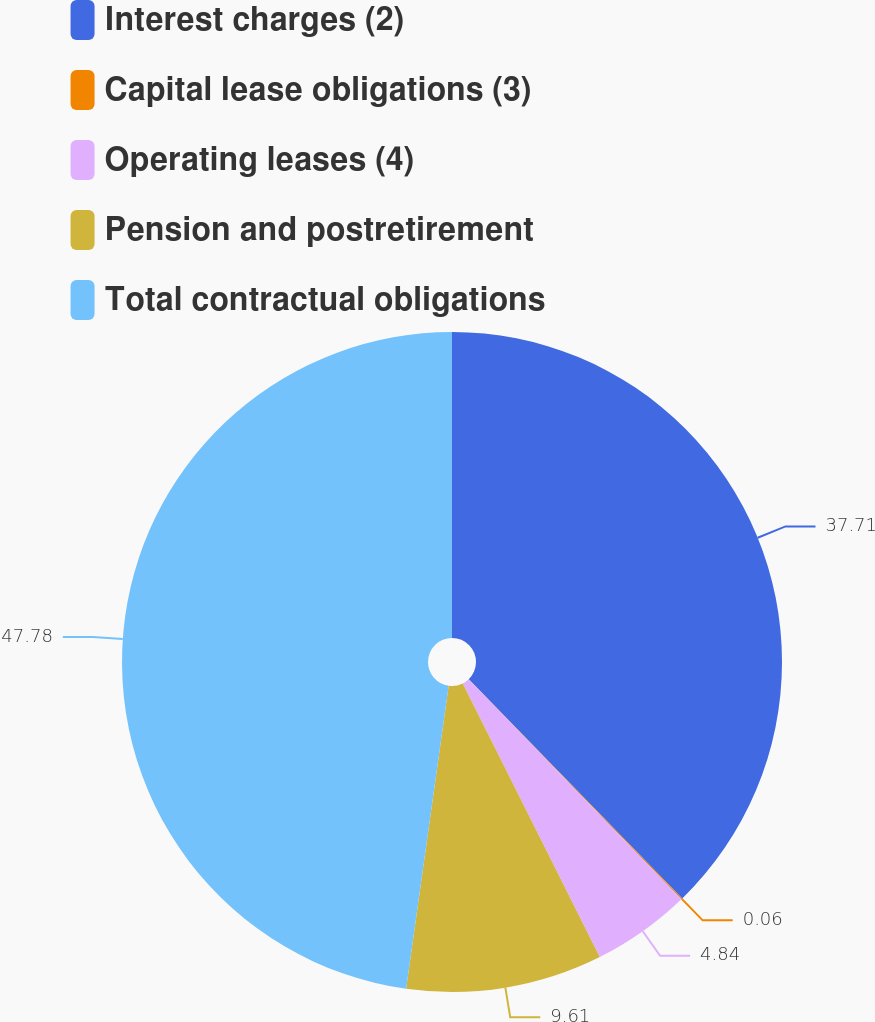<chart> <loc_0><loc_0><loc_500><loc_500><pie_chart><fcel>Interest charges (2)<fcel>Capital lease obligations (3)<fcel>Operating leases (4)<fcel>Pension and postretirement<fcel>Total contractual obligations<nl><fcel>37.71%<fcel>0.06%<fcel>4.84%<fcel>9.61%<fcel>47.78%<nl></chart> 